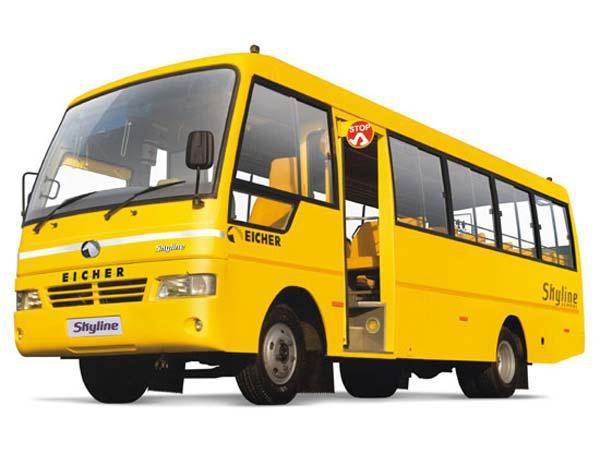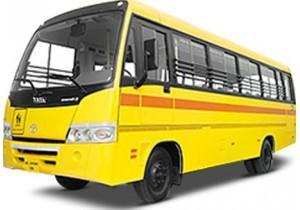The first image is the image on the left, the second image is the image on the right. Analyze the images presented: Is the assertion "Two school buses are angled in the same direction, one with side double doors behind the front tire, and the other with double doors in front of the tire." valid? Answer yes or no. No. The first image is the image on the left, the second image is the image on the right. Evaluate the accuracy of this statement regarding the images: "The buses in the left and right images face leftward, and neither bus has a driver behind the wheel.". Is it true? Answer yes or no. Yes. 